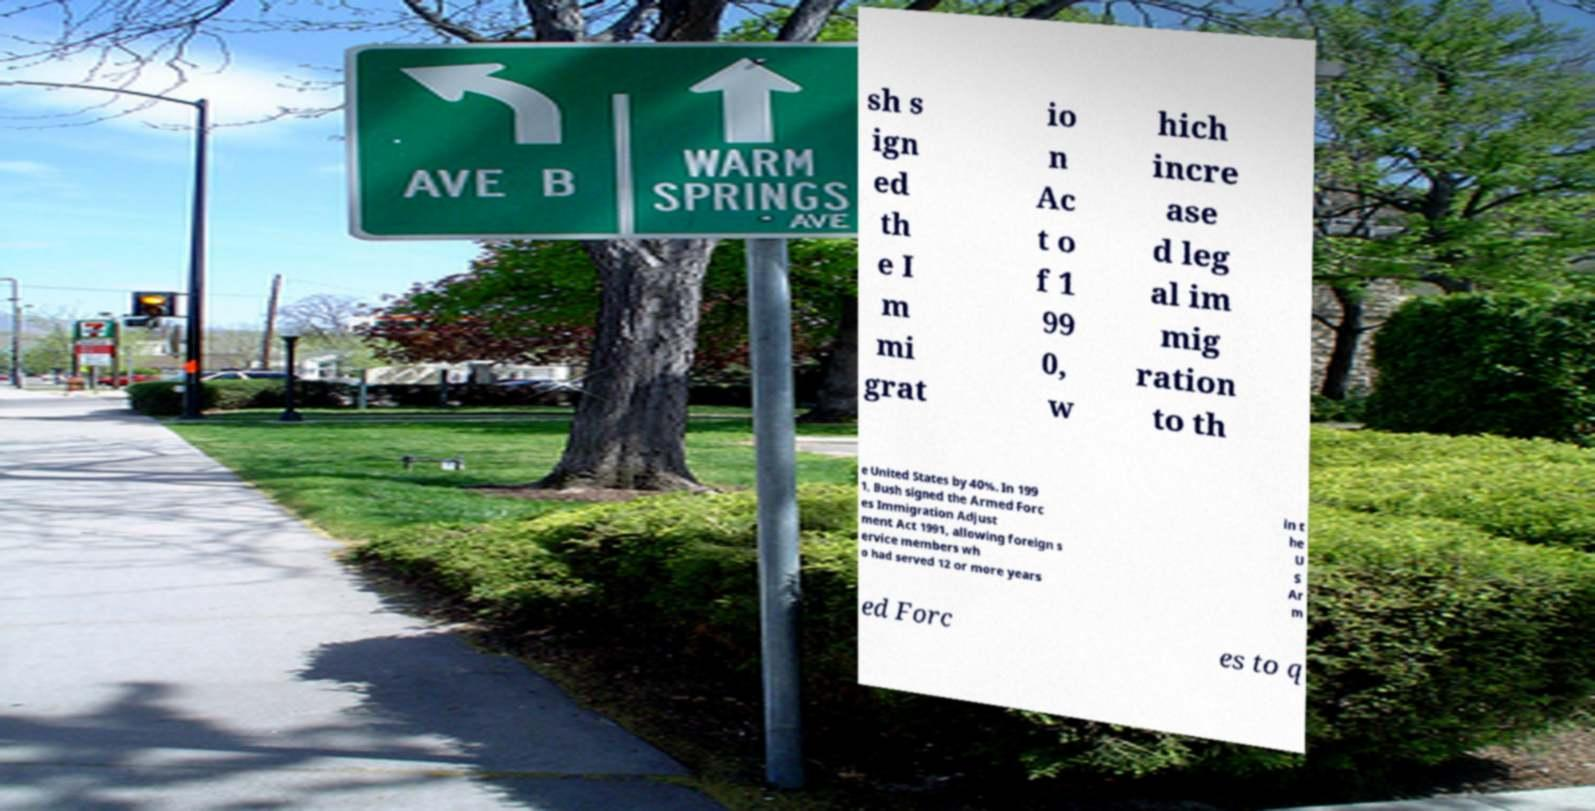Can you accurately transcribe the text from the provided image for me? sh s ign ed th e I m mi grat io n Ac t o f 1 99 0, w hich incre ase d leg al im mig ration to th e United States by 40%. In 199 1, Bush signed the Armed Forc es Immigration Adjust ment Act 1991, allowing foreign s ervice members wh o had served 12 or more years in t he U S Ar m ed Forc es to q 